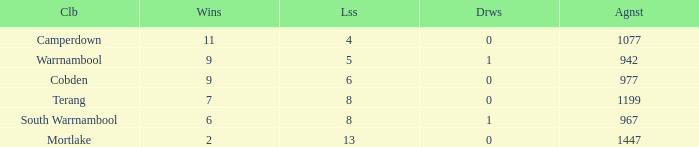What is the draw when the losses were more than 8 and less than 2 wins? None. 